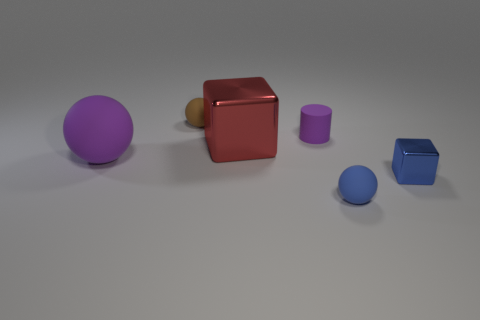Add 2 large cyan matte cylinders. How many objects exist? 8 Subtract all blocks. How many objects are left? 4 Subtract all matte balls. Subtract all big rubber spheres. How many objects are left? 2 Add 4 balls. How many balls are left? 7 Add 1 small purple cylinders. How many small purple cylinders exist? 2 Subtract 0 yellow cubes. How many objects are left? 6 